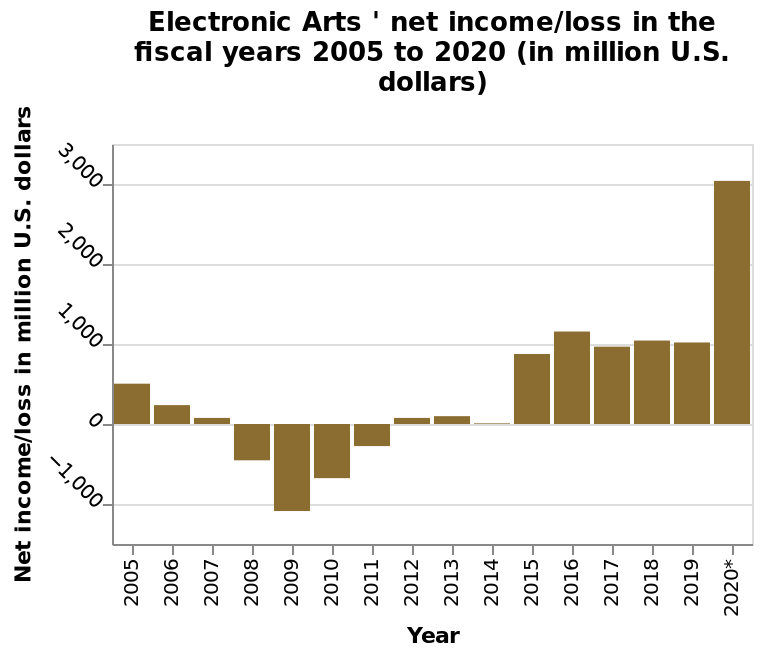<image>
Has the company had a net income above 0 since 2012?  Yes, the company has had a net income above 0 for every year since 2012. please enumerates aspects of the construction of the chart Electronic Arts ' net income/loss in the fiscal years 2005 to 2020 (in million U.S. dollars) is a bar diagram. There is a categorical scale starting with 2005 and ending with 2020* along the x-axis, labeled Year. The y-axis plots Net income/loss in million U.S. dollars. 